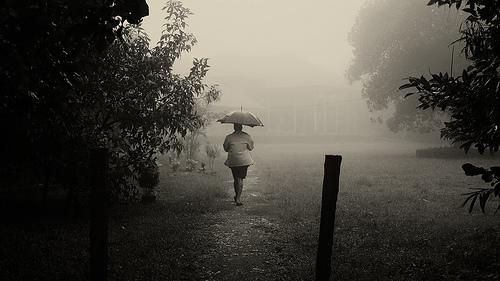Question: what kind of weather is this?
Choices:
A. Stormy.
B. Clear.
C. Hot.
D. Rain.
Answer with the letter. Answer: D Question: what is the white substance in the air?
Choices:
A. Smoke.
B. Fog.
C. Clouds.
D. Snow.
Answer with the letter. Answer: B Question: what kind of outerwear garment is the person wearing?
Choices:
A. Blanket.
B. Coat.
C. Plastic bag.
D. Poncho.
Answer with the letter. Answer: B 